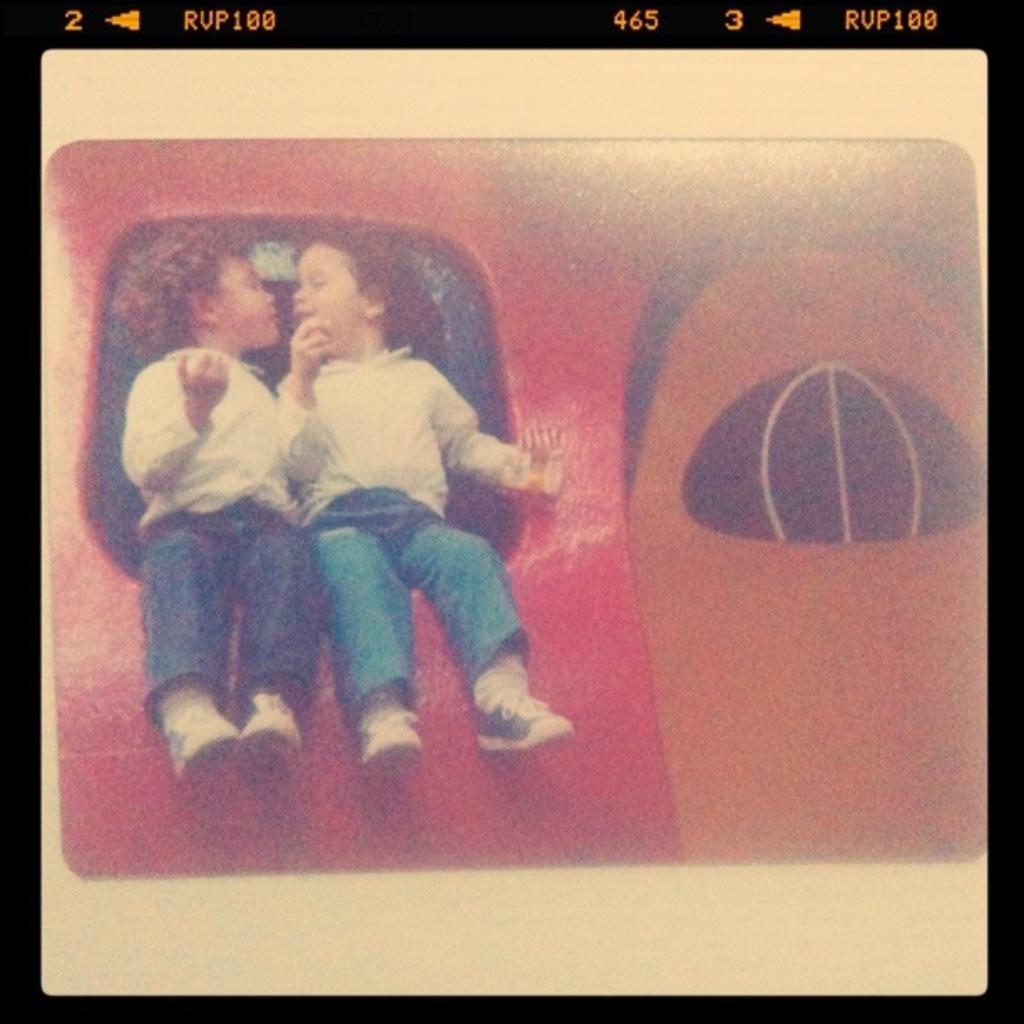What is the main feature of the image? There is a screen in the image. What can be seen on the screen? People are visible on the screen, along with objects, symbols, text, and numbers. Can you describe the symbols at the top of the screen? Unfortunately, the facts provided do not give specific details about the symbols on the screen. What type of information is displayed on the screen? The screen displays people, objects, symbols, text, and numbers. Can you see a man refueling an airplane on the screen? There is no mention of a man, an airplane, or fuel in the provided facts, so we cannot determine if they are present on the screen. 